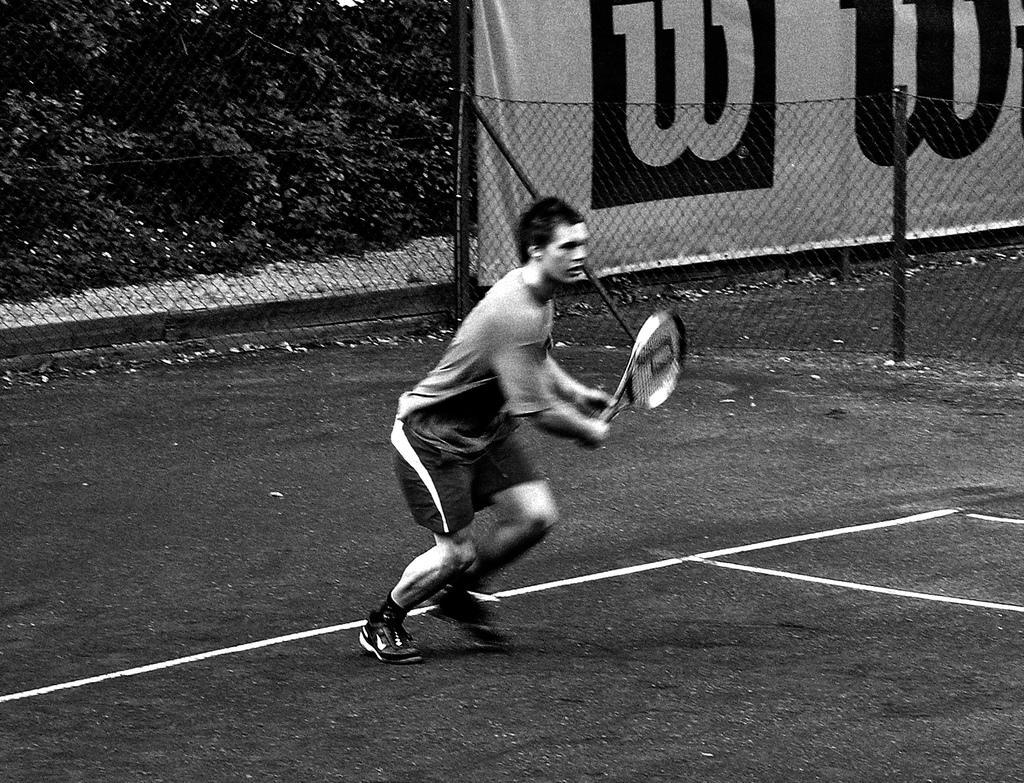How would you summarize this image in a sentence or two? Man standing holding a bat,here there is fencing and trees. 